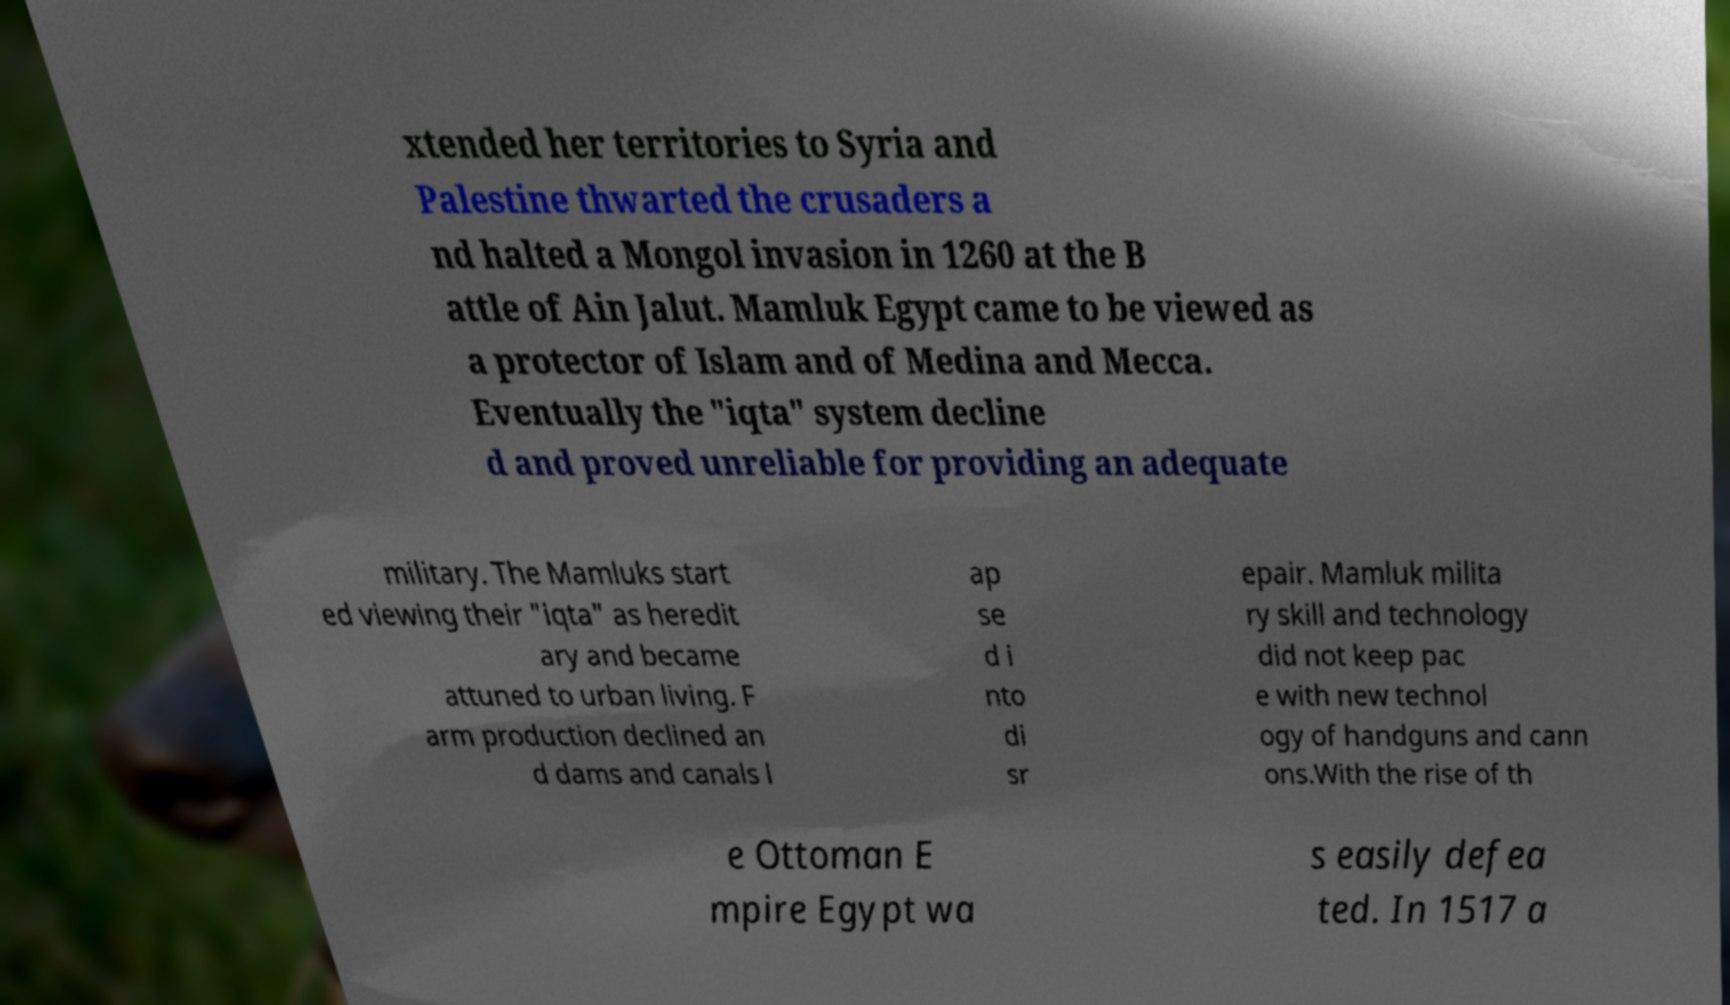Please identify and transcribe the text found in this image. xtended her territories to Syria and Palestine thwarted the crusaders a nd halted a Mongol invasion in 1260 at the B attle of Ain Jalut. Mamluk Egypt came to be viewed as a protector of Islam and of Medina and Mecca. Eventually the "iqta" system decline d and proved unreliable for providing an adequate military. The Mamluks start ed viewing their "iqta" as heredit ary and became attuned to urban living. F arm production declined an d dams and canals l ap se d i nto di sr epair. Mamluk milita ry skill and technology did not keep pac e with new technol ogy of handguns and cann ons.With the rise of th e Ottoman E mpire Egypt wa s easily defea ted. In 1517 a 